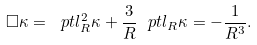Convert formula to latex. <formula><loc_0><loc_0><loc_500><loc_500>\square \kappa = \ p t l ^ { 2 } _ { R } \kappa + \frac { 3 } { R } \ p t l _ { R } \kappa = - \frac { 1 } { R ^ { 3 } } .</formula> 